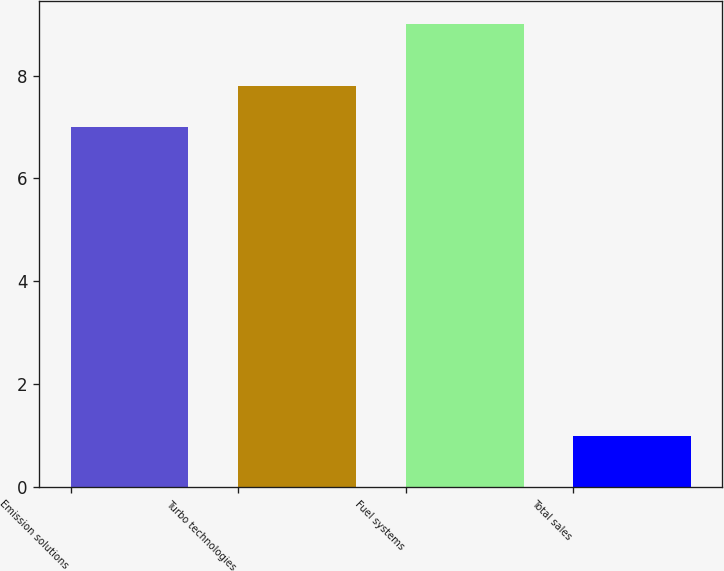Convert chart to OTSL. <chart><loc_0><loc_0><loc_500><loc_500><bar_chart><fcel>Emission solutions<fcel>Turbo technologies<fcel>Fuel systems<fcel>Total sales<nl><fcel>7<fcel>7.8<fcel>9<fcel>1<nl></chart> 